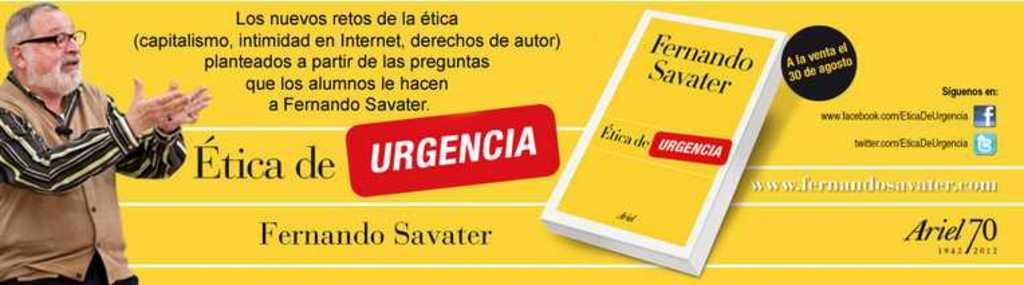<image>
Give a short and clear explanation of the subsequent image. A poster with the name Fernando Savater written in black. 